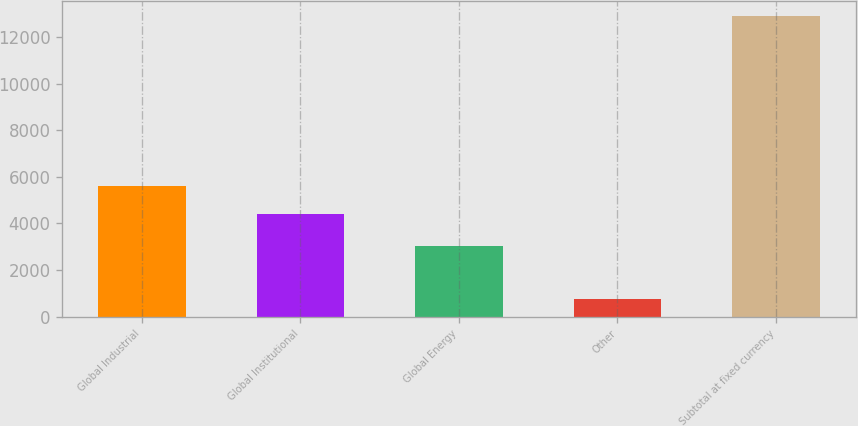Convert chart to OTSL. <chart><loc_0><loc_0><loc_500><loc_500><bar_chart><fcel>Global Industrial<fcel>Global Institutional<fcel>Global Energy<fcel>Other<fcel>Subtotal at fixed currency<nl><fcel>5624.17<fcel>4411.2<fcel>3042.3<fcel>772.8<fcel>12902.5<nl></chart> 